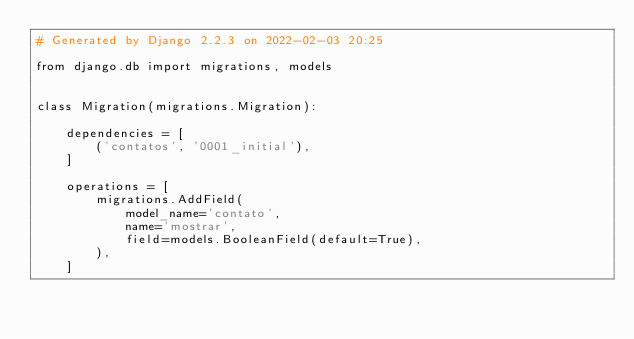Convert code to text. <code><loc_0><loc_0><loc_500><loc_500><_Python_># Generated by Django 2.2.3 on 2022-02-03 20:25

from django.db import migrations, models


class Migration(migrations.Migration):

    dependencies = [
        ('contatos', '0001_initial'),
    ]

    operations = [
        migrations.AddField(
            model_name='contato',
            name='mostrar',
            field=models.BooleanField(default=True),
        ),
    ]
</code> 